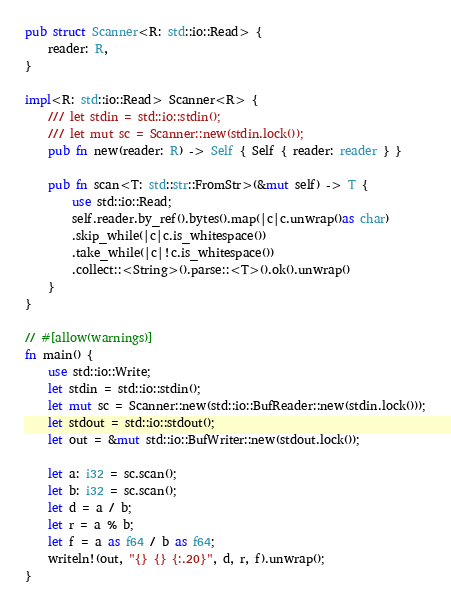<code> <loc_0><loc_0><loc_500><loc_500><_Rust_>pub struct Scanner<R: std::io::Read> {
    reader: R,
}

impl<R: std::io::Read> Scanner<R> {
    /// let stdin = std::io::stdin();
    /// let mut sc = Scanner::new(stdin.lock());
    pub fn new(reader: R) -> Self { Self { reader: reader } }

    pub fn scan<T: std::str::FromStr>(&mut self) -> T {
        use std::io::Read;
        self.reader.by_ref().bytes().map(|c|c.unwrap()as char)
        .skip_while(|c|c.is_whitespace())
        .take_while(|c|!c.is_whitespace())
        .collect::<String>().parse::<T>().ok().unwrap()
    }
}

// #[allow(warnings)]
fn main() {
    use std::io::Write;
    let stdin = std::io::stdin();
    let mut sc = Scanner::new(std::io::BufReader::new(stdin.lock()));
    let stdout = std::io::stdout();
    let out = &mut std::io::BufWriter::new(stdout.lock());

    let a: i32 = sc.scan();
    let b: i32 = sc.scan();
    let d = a / b;
    let r = a % b;
    let f = a as f64 / b as f64;
    writeln!(out, "{} {} {:.20}", d, r, f).unwrap();
}


</code> 